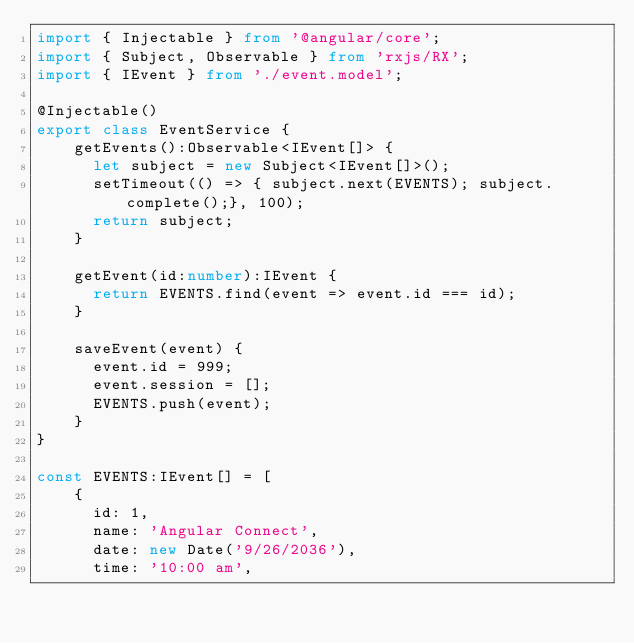<code> <loc_0><loc_0><loc_500><loc_500><_TypeScript_>import { Injectable } from '@angular/core';
import { Subject, Observable } from 'rxjs/RX';
import { IEvent } from './event.model';

@Injectable()
export class EventService {
    getEvents():Observable<IEvent[]> {
      let subject = new Subject<IEvent[]>();
      setTimeout(() => { subject.next(EVENTS); subject.complete();}, 100);
      return subject;
    }

    getEvent(id:number):IEvent {
      return EVENTS.find(event => event.id === id);
    }

    saveEvent(event) {
      event.id = 999;
      event.session = [];
      EVENTS.push(event);
    }
}

const EVENTS:IEvent[] = [
    {
      id: 1,
      name: 'Angular Connect',
      date: new Date('9/26/2036'),
      time: '10:00 am',</code> 